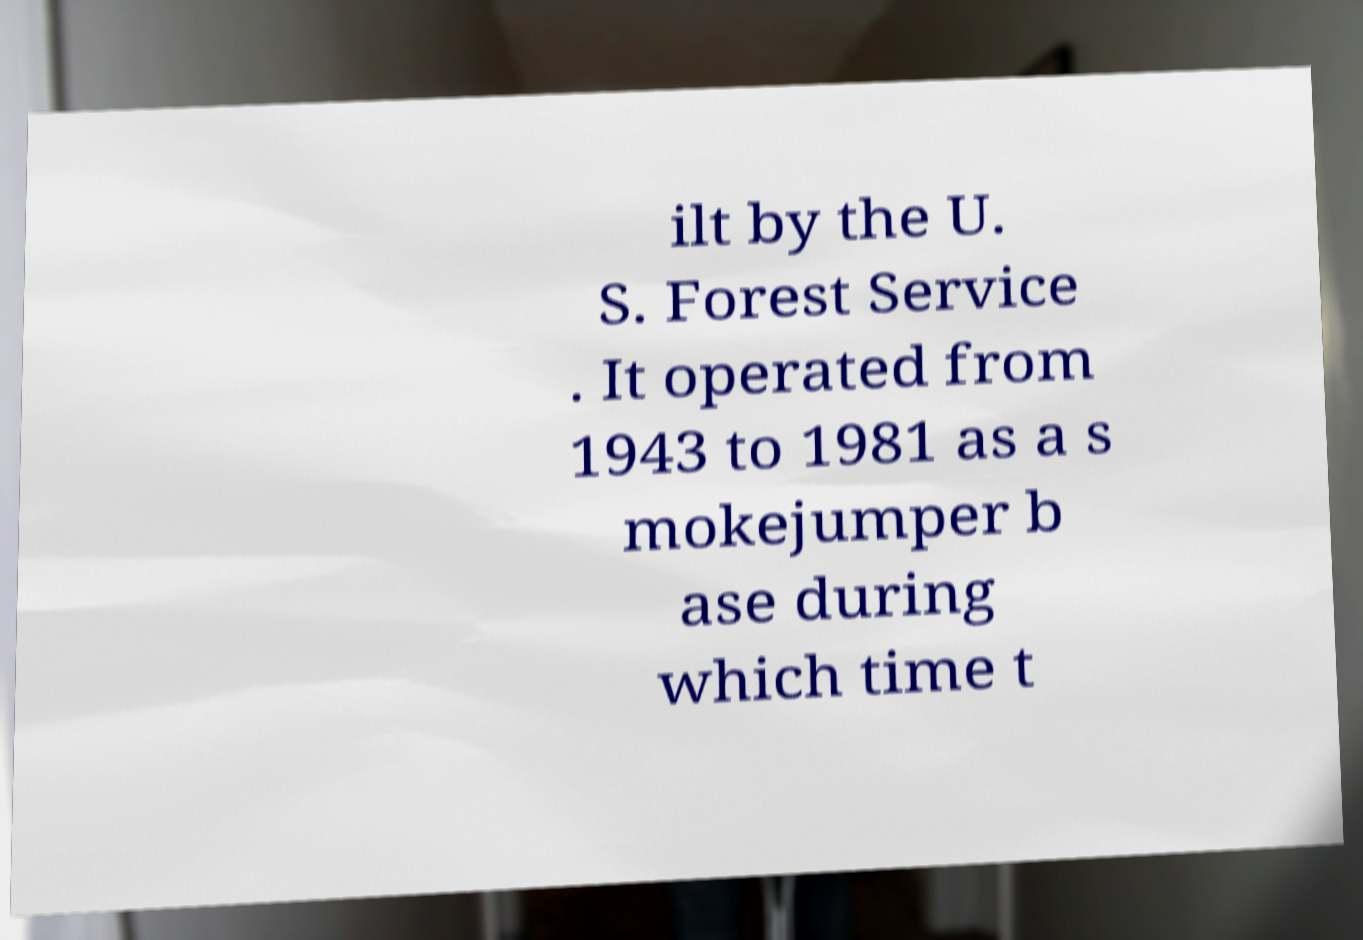Could you assist in decoding the text presented in this image and type it out clearly? ilt by the U. S. Forest Service . It operated from 1943 to 1981 as a s mokejumper b ase during which time t 